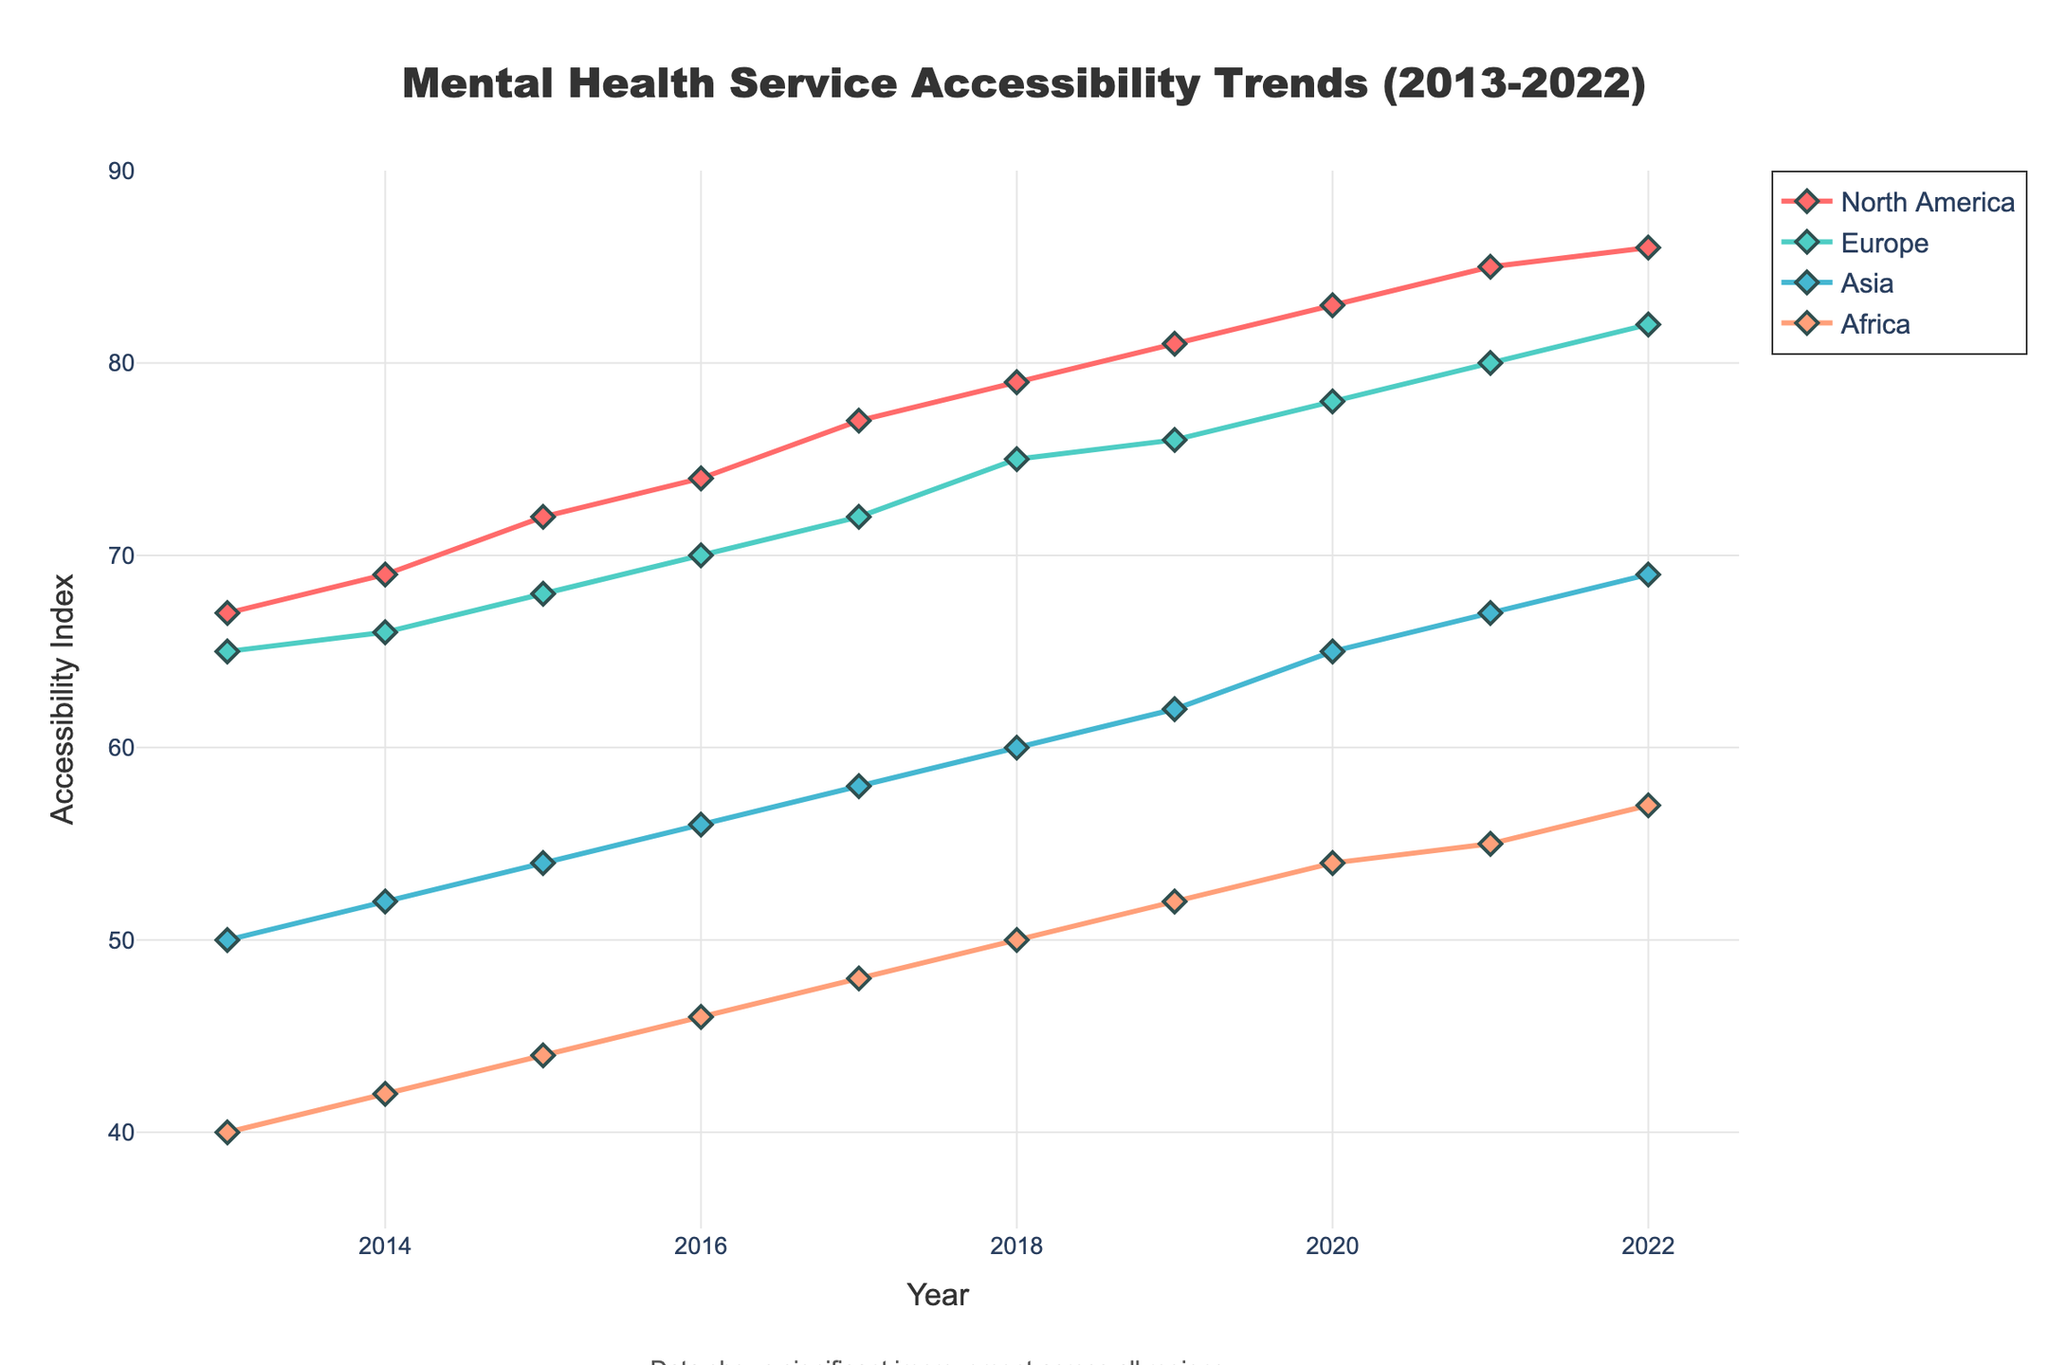What is the title of the plot? The title of the plot is located at the top center of the figure. It is visibly displayed in bold text.
Answer: Mental Health Service Accessibility Trends (2013-2022) Which region has the highest Accessibility Index in 2022? The Accessibility Index values for each region in 2022 can be read from the corresponding lines' endpoints. North America's line is at the topmost position.
Answer: North America How has the Accessibility Index in Europe changed from 2013 to 2022? Look at the line representing Europe and observe its starting and ending points. The index starts at 65 in 2013 and ends at 82 in 2022, indicating an increasing trend.
Answer: Increased What is the range of the Y-axis? The Y-axis represents the Accessibility Index and the numerical range can be read from the axis itself. It goes from 35 to 90.
Answer: 35 to 90 On average, how much did the Accessibility Index in Africa increase per year from 2013 to 2022? Calculate the total change by subtracting the 2013 value from the 2022 value (57 - 40 = 17). Then, divide the difference by the number of years (2022 - 2013 = 9). The average annual increase is 17/9 ≈ 1.89.
Answer: Approximately 1.89 Which region had the lowest Accessibility Index in 2013? Compare the starting points of all lines at the 2013 mark. The line for Africa starts at the lowest point, with an index of 40.
Answer: Africa By how many points did the Accessibility Index in Asia increase from 2015 to 2020? Identify the points on the Asia line for 2015 (54) and 2020 (65). Subtract to find the difference (65 - 54 = 11).
Answer: 11 Which two regions experienced the greatest improvement in Accessibility Index from 2013 to 2022? Examine the overall increase in the index for each region by comparing their starting and ending points. North America (86-67=19) and Europe (82-65=17) have the highest improvements.
Answer: North America and Europe How does the trend in Africa compare to the trend in Asia over the plotted years? Both regions show an increasing trend, but Africa starts lower and ends lower compared to Asia. Visually, Africa shows a more gradual increase, while Asia shows a slightly steeper increase over time.
Answer: Both are increasing, Asia more steeply 